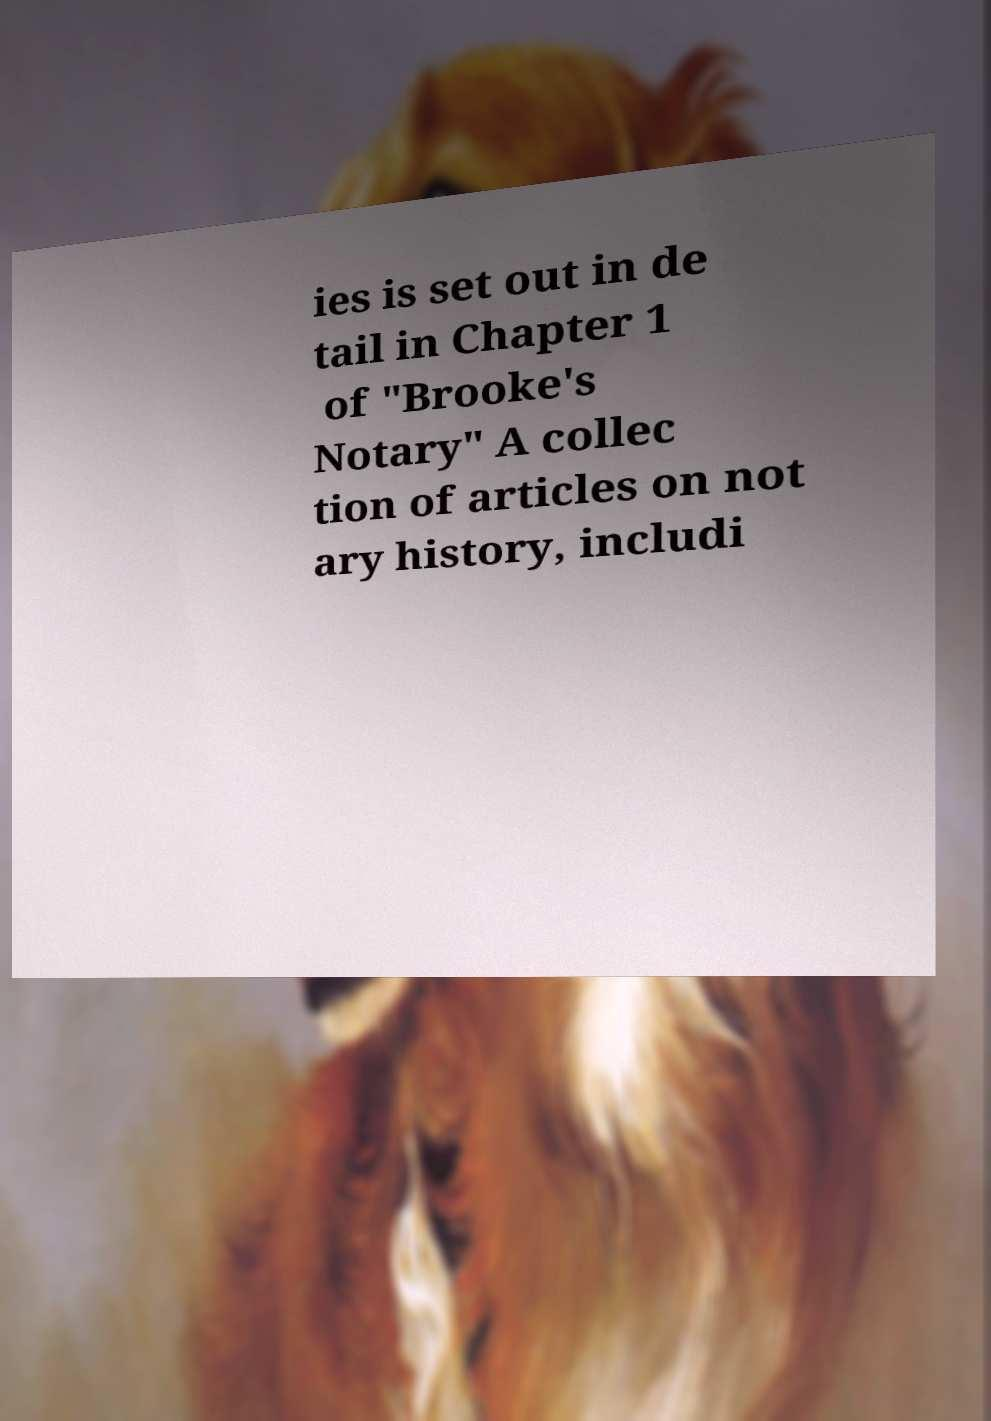What messages or text are displayed in this image? I need them in a readable, typed format. ies is set out in de tail in Chapter 1 of "Brooke's Notary" A collec tion of articles on not ary history, includi 